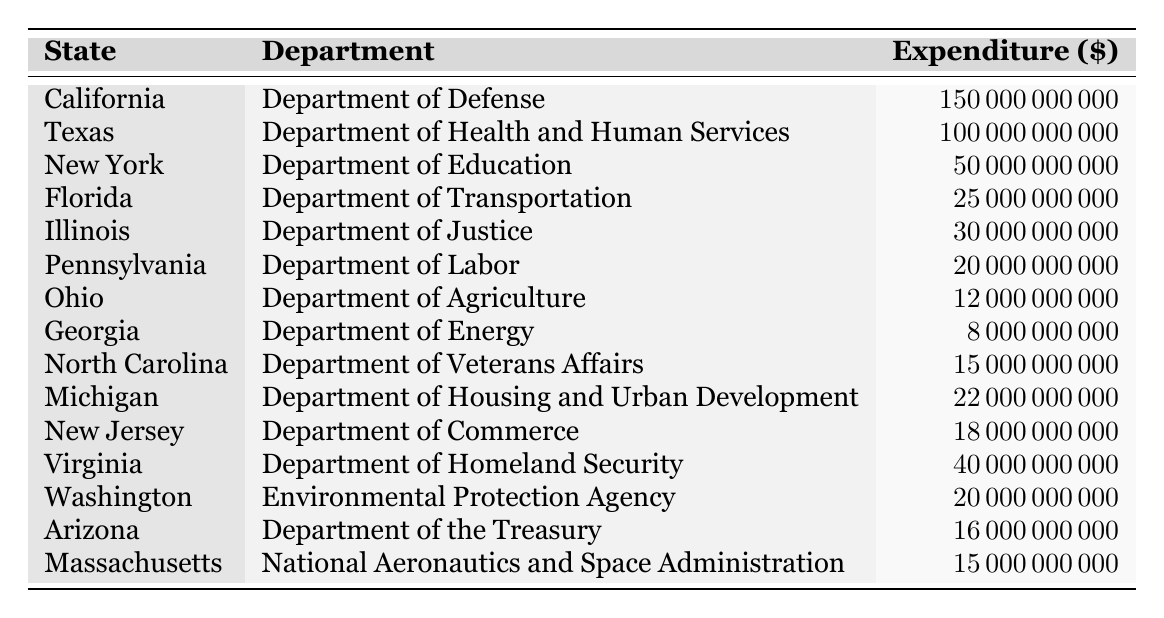What is the highest expenditure recorded in the table? The table lists various expenditures by state and department. Scanning through the expenditures, California's expenditure of 150 billion is the highest.
Answer: 150 billion Which state received the second highest federal budget expenditure? After identifying California as the state with the highest expenditure, I move to the next highest, which is Texas with an expenditure of 100 billion.
Answer: Texas What is the total expenditure of all listed states? To find the total expenditure, I sum all individual expenditures: 150 billion + 100 billion + 50 billion + 25 billion + 30 billion + 20 billion + 12 billion + 8 billion + 15 billion + 22 billion + 18 billion + 40 billion + 20 billion + 16 billion + 15 billion = 576 billion.
Answer: 576 billion How much did Florida spend compared to Pennsylvania? Florida spent 25 billion, while Pennsylvania spent 20 billion. Therefore, Florida spent 5 billion more than Pennsylvania.
Answer: Florida spent 5 billion more Is there any state that spent less than 10 billion? Scanning the expenditures, Georgia at 8 billion is the only state with a expenditure below 10 billion.
Answer: Yes What is the total expenditure of the Department of Education and the Department of Health and Human Services combined? The Department of Education in New York spent 50 billion, and the Department of Health and Human Services in Texas spent 100 billion. Adding these together gives 50 billion + 100 billion = 150 billion.
Answer: 150 billion Which state has the expenditure closest to 20 billion? Checking the data, both Pennsylvania and Washington have an expenditure of 20 billion. However, the nearest value above is Virginia with 40 billion and below is Ohio with 12 billion. Thus, the closest expenditures are Pennsylvania and Washington at 20 billion.
Answer: Pennsylvania and Washington (20 billion) What is the difference in expenditure between the Department of Defense and the Department of Justice? The Department of Defense in California has an expenditure of 150 billion and the Department of Justice in Illinois has an expenditure of 30 billion. The difference can be calculated: 150 billion - 30 billion = 120 billion.
Answer: 120 billion How much more did the Department of Energy spend than the Department of Transportation? The Department of Energy in Georgia spent 8 billion, while the Department of Transportation in Florida spent 25 billion. The calculation shows that 25 billion - 8 billion = 17 billion, meaning Transportation spent 17 billion more.
Answer: Transportation spent 17 billion more Which department received more funds, the Department of Justice or the Department of Labor? The Department of Justice in Illinois received 30 billion, while the Department of Labor in Pennsylvania received 20 billion. So, the Department of Justice received 10 billion more than the Department of Labor.
Answer: Department of Justice received 10 billion more 